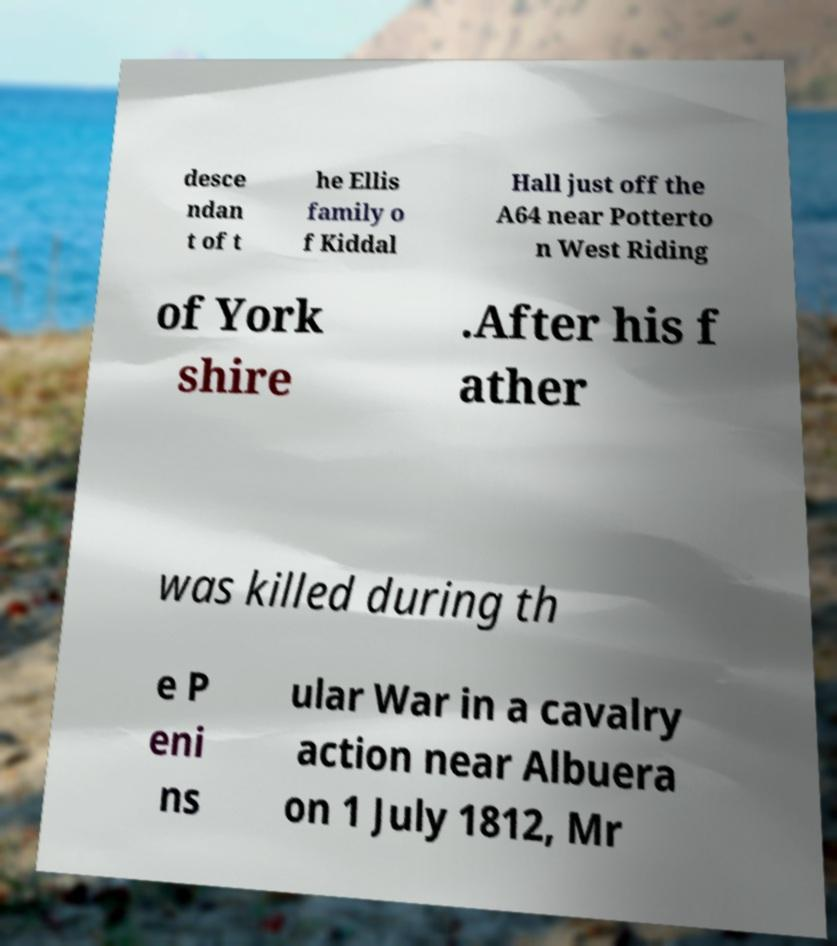Could you extract and type out the text from this image? desce ndan t of t he Ellis family o f Kiddal Hall just off the A64 near Potterto n West Riding of York shire .After his f ather was killed during th e P eni ns ular War in a cavalry action near Albuera on 1 July 1812, Mr 